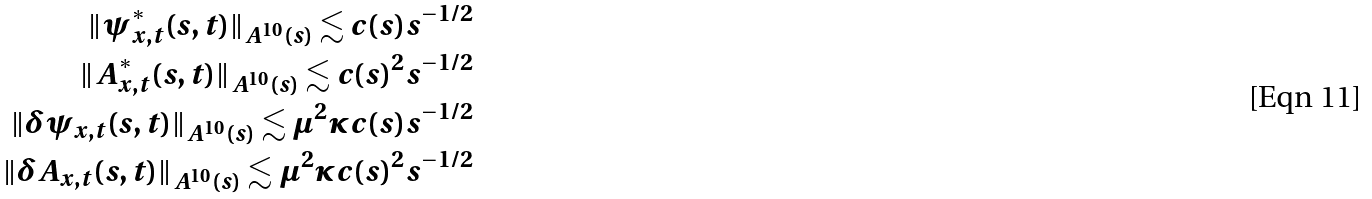<formula> <loc_0><loc_0><loc_500><loc_500>\| \psi ^ { * } _ { x , t } ( s , t ) \| _ { A ^ { 1 0 } ( s ) } \lesssim c ( s ) s ^ { - 1 / 2 } \\ \| A ^ { * } _ { x , t } ( s , t ) \| _ { A ^ { 1 0 } ( s ) } \lesssim c ( s ) ^ { 2 } s ^ { - 1 / 2 } \\ \| \delta \psi _ { x , t } ( s , t ) \| _ { A ^ { 1 0 } ( s ) } \lesssim \mu ^ { 2 } \kappa c ( s ) s ^ { - 1 / 2 } \\ \| \delta A _ { x , t } ( s , t ) \| _ { A ^ { 1 0 } ( s ) } \lesssim \mu ^ { 2 } \kappa c ( s ) ^ { 2 } s ^ { - 1 / 2 }</formula> 